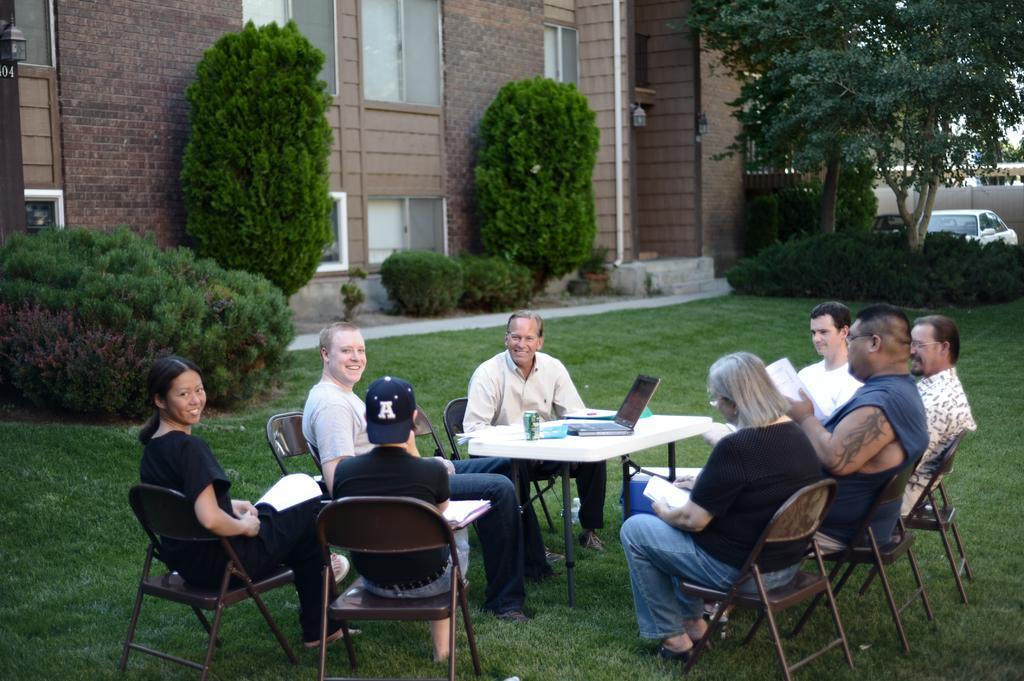In one or two sentences, can you explain what this image depicts? This Picture describe the a view of the garden in which a group of people are sitting around on the chair, In the middle white table on which the laptop is placed, Center man is smiling and looking in the camera, Behind we can see the red brick building and some trees around it. And white color car parked at the extreme corner of the Boundary wall. 